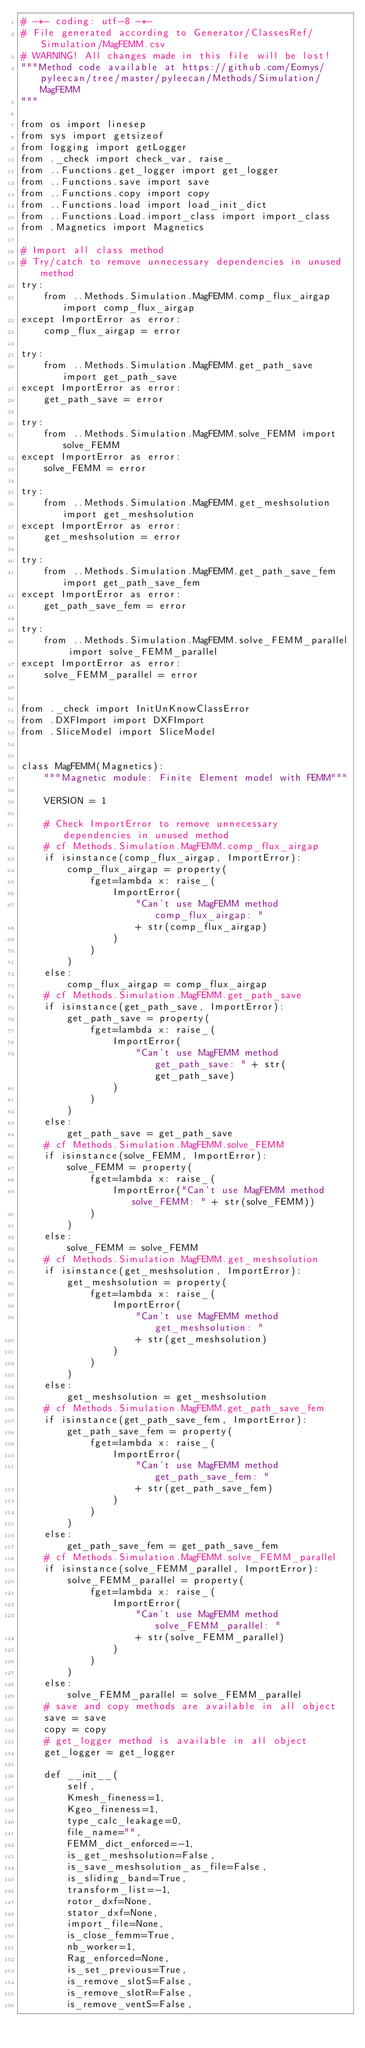<code> <loc_0><loc_0><loc_500><loc_500><_Python_># -*- coding: utf-8 -*-
# File generated according to Generator/ClassesRef/Simulation/MagFEMM.csv
# WARNING! All changes made in this file will be lost!
"""Method code available at https://github.com/Eomys/pyleecan/tree/master/pyleecan/Methods/Simulation/MagFEMM
"""

from os import linesep
from sys import getsizeof
from logging import getLogger
from ._check import check_var, raise_
from ..Functions.get_logger import get_logger
from ..Functions.save import save
from ..Functions.copy import copy
from ..Functions.load import load_init_dict
from ..Functions.Load.import_class import import_class
from .Magnetics import Magnetics

# Import all class method
# Try/catch to remove unnecessary dependencies in unused method
try:
    from ..Methods.Simulation.MagFEMM.comp_flux_airgap import comp_flux_airgap
except ImportError as error:
    comp_flux_airgap = error

try:
    from ..Methods.Simulation.MagFEMM.get_path_save import get_path_save
except ImportError as error:
    get_path_save = error

try:
    from ..Methods.Simulation.MagFEMM.solve_FEMM import solve_FEMM
except ImportError as error:
    solve_FEMM = error

try:
    from ..Methods.Simulation.MagFEMM.get_meshsolution import get_meshsolution
except ImportError as error:
    get_meshsolution = error

try:
    from ..Methods.Simulation.MagFEMM.get_path_save_fem import get_path_save_fem
except ImportError as error:
    get_path_save_fem = error

try:
    from ..Methods.Simulation.MagFEMM.solve_FEMM_parallel import solve_FEMM_parallel
except ImportError as error:
    solve_FEMM_parallel = error


from ._check import InitUnKnowClassError
from .DXFImport import DXFImport
from .SliceModel import SliceModel


class MagFEMM(Magnetics):
    """Magnetic module: Finite Element model with FEMM"""

    VERSION = 1

    # Check ImportError to remove unnecessary dependencies in unused method
    # cf Methods.Simulation.MagFEMM.comp_flux_airgap
    if isinstance(comp_flux_airgap, ImportError):
        comp_flux_airgap = property(
            fget=lambda x: raise_(
                ImportError(
                    "Can't use MagFEMM method comp_flux_airgap: "
                    + str(comp_flux_airgap)
                )
            )
        )
    else:
        comp_flux_airgap = comp_flux_airgap
    # cf Methods.Simulation.MagFEMM.get_path_save
    if isinstance(get_path_save, ImportError):
        get_path_save = property(
            fget=lambda x: raise_(
                ImportError(
                    "Can't use MagFEMM method get_path_save: " + str(get_path_save)
                )
            )
        )
    else:
        get_path_save = get_path_save
    # cf Methods.Simulation.MagFEMM.solve_FEMM
    if isinstance(solve_FEMM, ImportError):
        solve_FEMM = property(
            fget=lambda x: raise_(
                ImportError("Can't use MagFEMM method solve_FEMM: " + str(solve_FEMM))
            )
        )
    else:
        solve_FEMM = solve_FEMM
    # cf Methods.Simulation.MagFEMM.get_meshsolution
    if isinstance(get_meshsolution, ImportError):
        get_meshsolution = property(
            fget=lambda x: raise_(
                ImportError(
                    "Can't use MagFEMM method get_meshsolution: "
                    + str(get_meshsolution)
                )
            )
        )
    else:
        get_meshsolution = get_meshsolution
    # cf Methods.Simulation.MagFEMM.get_path_save_fem
    if isinstance(get_path_save_fem, ImportError):
        get_path_save_fem = property(
            fget=lambda x: raise_(
                ImportError(
                    "Can't use MagFEMM method get_path_save_fem: "
                    + str(get_path_save_fem)
                )
            )
        )
    else:
        get_path_save_fem = get_path_save_fem
    # cf Methods.Simulation.MagFEMM.solve_FEMM_parallel
    if isinstance(solve_FEMM_parallel, ImportError):
        solve_FEMM_parallel = property(
            fget=lambda x: raise_(
                ImportError(
                    "Can't use MagFEMM method solve_FEMM_parallel: "
                    + str(solve_FEMM_parallel)
                )
            )
        )
    else:
        solve_FEMM_parallel = solve_FEMM_parallel
    # save and copy methods are available in all object
    save = save
    copy = copy
    # get_logger method is available in all object
    get_logger = get_logger

    def __init__(
        self,
        Kmesh_fineness=1,
        Kgeo_fineness=1,
        type_calc_leakage=0,
        file_name="",
        FEMM_dict_enforced=-1,
        is_get_meshsolution=False,
        is_save_meshsolution_as_file=False,
        is_sliding_band=True,
        transform_list=-1,
        rotor_dxf=None,
        stator_dxf=None,
        import_file=None,
        is_close_femm=True,
        nb_worker=1,
        Rag_enforced=None,
        is_set_previous=True,
        is_remove_slotS=False,
        is_remove_slotR=False,
        is_remove_ventS=False,</code> 